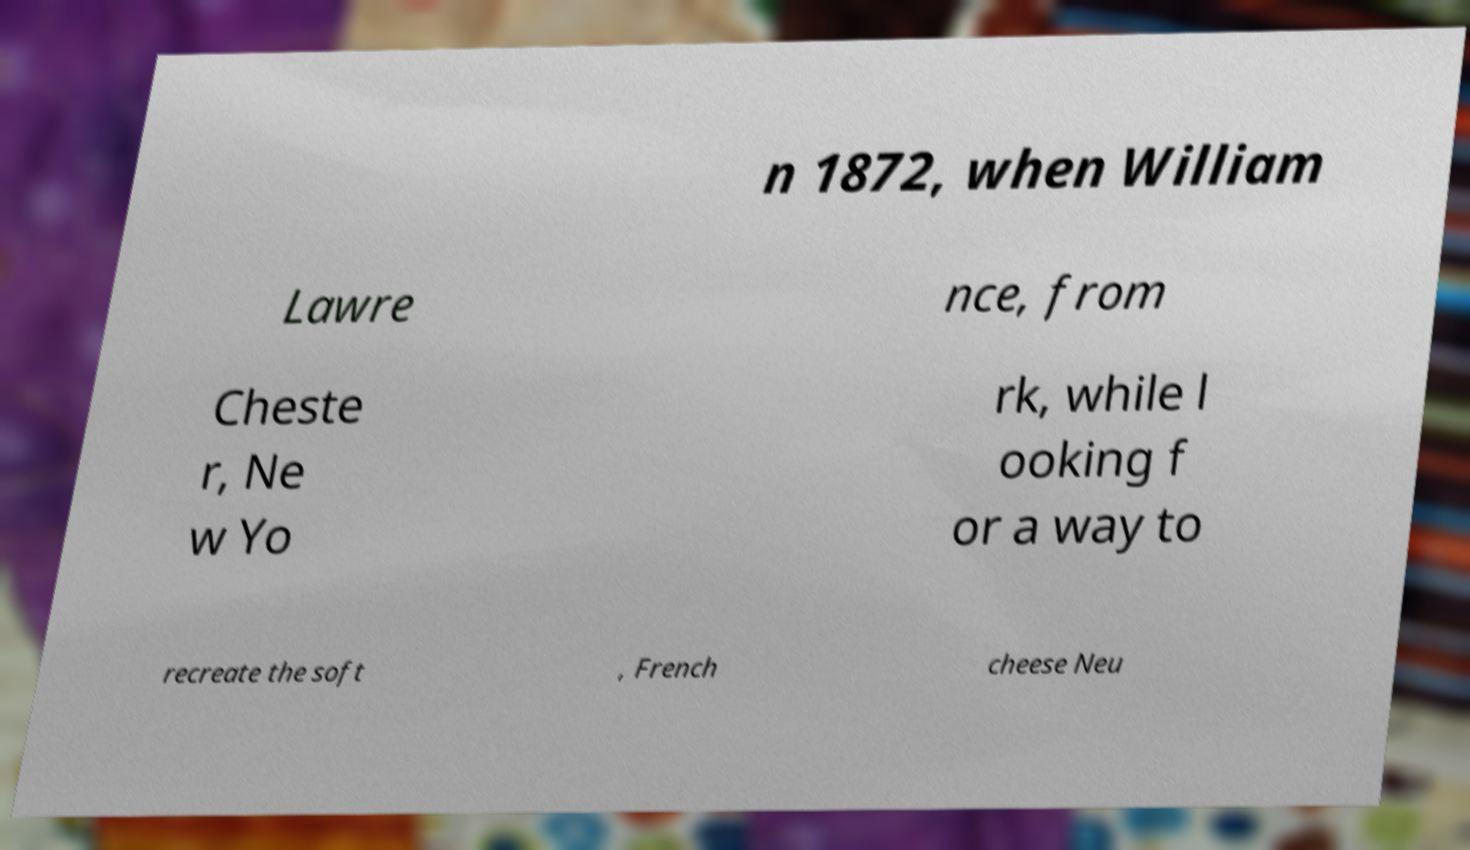Please identify and transcribe the text found in this image. n 1872, when William Lawre nce, from Cheste r, Ne w Yo rk, while l ooking f or a way to recreate the soft , French cheese Neu 